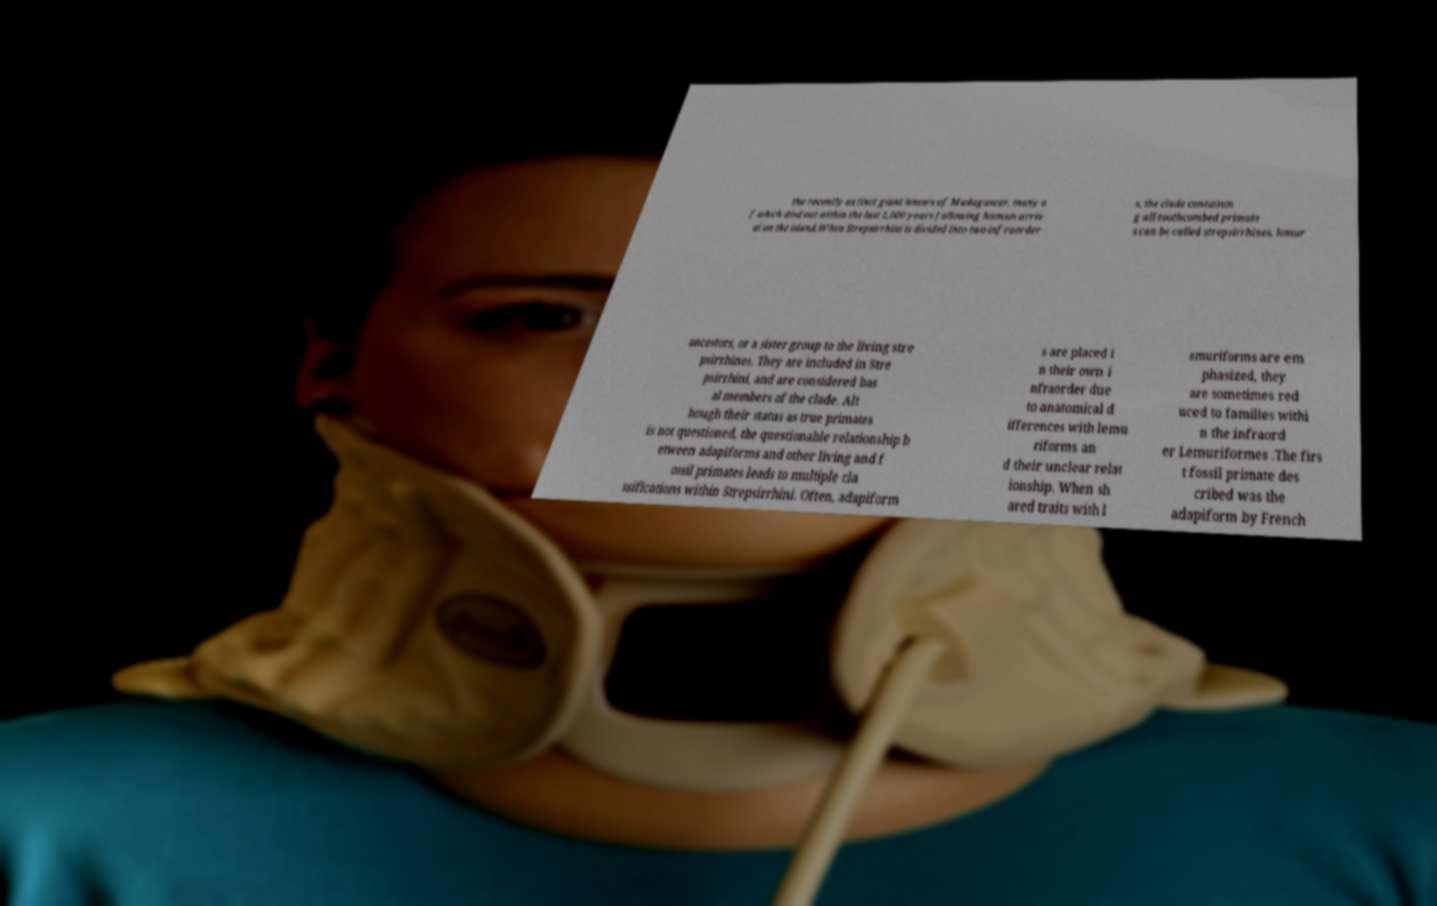There's text embedded in this image that I need extracted. Can you transcribe it verbatim? the recently extinct giant lemurs of Madagascar, many o f which died out within the last 1,000 years following human arriv al on the island.When Strepsirrhini is divided into two infraorder s, the clade containin g all toothcombed primate s can be called strepsirrhines, lemur ancestors, or a sister group to the living stre psirrhines. They are included in Stre psirrhini, and are considered bas al members of the clade. Alt hough their status as true primates is not questioned, the questionable relationship b etween adapiforms and other living and f ossil primates leads to multiple cla ssifications within Strepsirrhini. Often, adapiform s are placed i n their own i nfraorder due to anatomical d ifferences with lemu riforms an d their unclear relat ionship. When sh ared traits with l emuriforms are em phasized, they are sometimes red uced to families withi n the infraord er Lemuriformes .The firs t fossil primate des cribed was the adapiform by French 